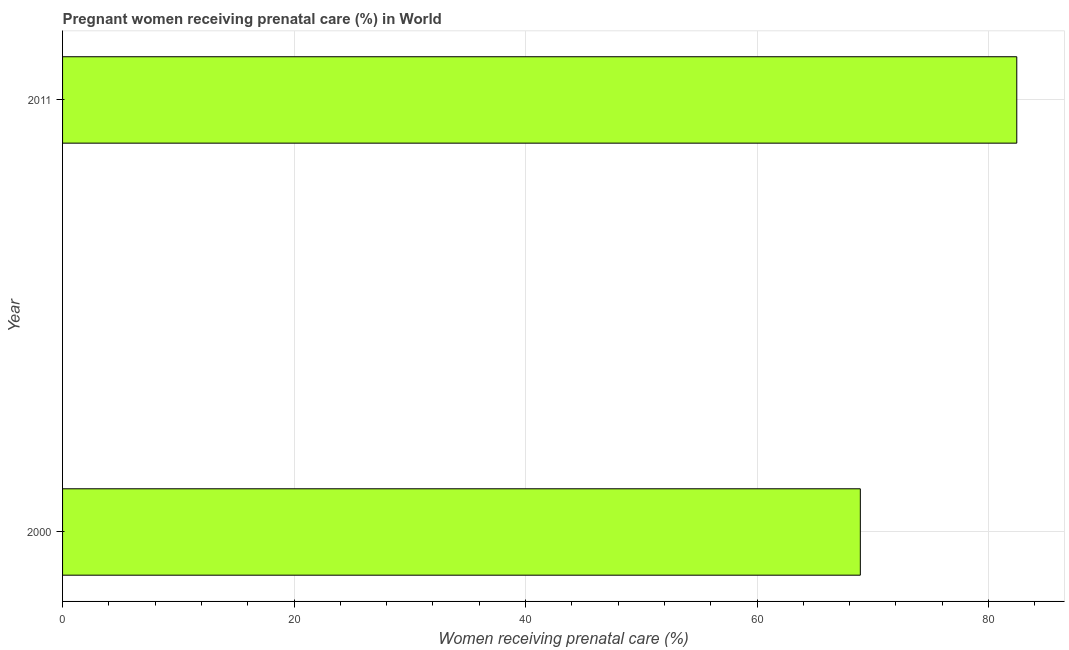Does the graph contain grids?
Provide a succinct answer. Yes. What is the title of the graph?
Provide a short and direct response. Pregnant women receiving prenatal care (%) in World. What is the label or title of the X-axis?
Your answer should be very brief. Women receiving prenatal care (%). What is the percentage of pregnant women receiving prenatal care in 2000?
Your answer should be very brief. 68.92. Across all years, what is the maximum percentage of pregnant women receiving prenatal care?
Offer a very short reply. 82.44. Across all years, what is the minimum percentage of pregnant women receiving prenatal care?
Your answer should be compact. 68.92. In which year was the percentage of pregnant women receiving prenatal care maximum?
Offer a terse response. 2011. What is the sum of the percentage of pregnant women receiving prenatal care?
Offer a terse response. 151.36. What is the difference between the percentage of pregnant women receiving prenatal care in 2000 and 2011?
Give a very brief answer. -13.52. What is the average percentage of pregnant women receiving prenatal care per year?
Offer a very short reply. 75.68. What is the median percentage of pregnant women receiving prenatal care?
Provide a succinct answer. 75.68. In how many years, is the percentage of pregnant women receiving prenatal care greater than 72 %?
Give a very brief answer. 1. Do a majority of the years between 2000 and 2011 (inclusive) have percentage of pregnant women receiving prenatal care greater than 12 %?
Your answer should be very brief. Yes. What is the ratio of the percentage of pregnant women receiving prenatal care in 2000 to that in 2011?
Provide a short and direct response. 0.84. Is the percentage of pregnant women receiving prenatal care in 2000 less than that in 2011?
Your answer should be compact. Yes. In how many years, is the percentage of pregnant women receiving prenatal care greater than the average percentage of pregnant women receiving prenatal care taken over all years?
Your answer should be very brief. 1. How many bars are there?
Ensure brevity in your answer.  2. What is the Women receiving prenatal care (%) in 2000?
Your response must be concise. 68.92. What is the Women receiving prenatal care (%) of 2011?
Offer a very short reply. 82.44. What is the difference between the Women receiving prenatal care (%) in 2000 and 2011?
Give a very brief answer. -13.52. What is the ratio of the Women receiving prenatal care (%) in 2000 to that in 2011?
Your answer should be compact. 0.84. 